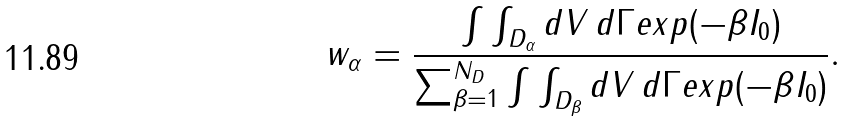<formula> <loc_0><loc_0><loc_500><loc_500>w _ { \alpha } = \frac { \int \int _ { D _ { \alpha } } d V \, d \Gamma e x p ( - \beta I _ { 0 } ) } { \sum _ { \beta = 1 } ^ { N _ { D } } \int \int _ { D _ { \beta } } d V \, d \Gamma e x p ( - \beta I _ { 0 } ) } .</formula> 